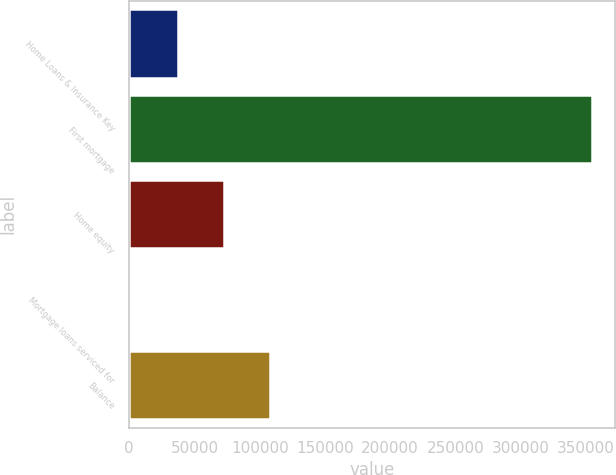Convert chart to OTSL. <chart><loc_0><loc_0><loc_500><loc_500><bar_chart><fcel>Home Loans & Insurance Key<fcel>First mortgage<fcel>Home equity<fcel>Mortgage loans serviced for<fcel>Balance<nl><fcel>36995<fcel>354506<fcel>72274<fcel>1716<fcel>107553<nl></chart> 